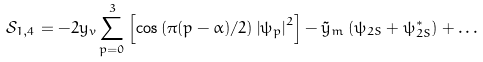Convert formula to latex. <formula><loc_0><loc_0><loc_500><loc_500>\mathcal { S } _ { 1 , 4 } = - 2 y _ { v } \sum _ { p = 0 } ^ { 3 } \left [ \cos \left ( \pi ( p - \alpha ) / 2 \right ) \left | \psi _ { p } \right | ^ { 2 } \right ] - \tilde { y } _ { m } \left ( \psi _ { 2 S } + \psi _ { 2 S } ^ { \ast } \right ) + \dots</formula> 